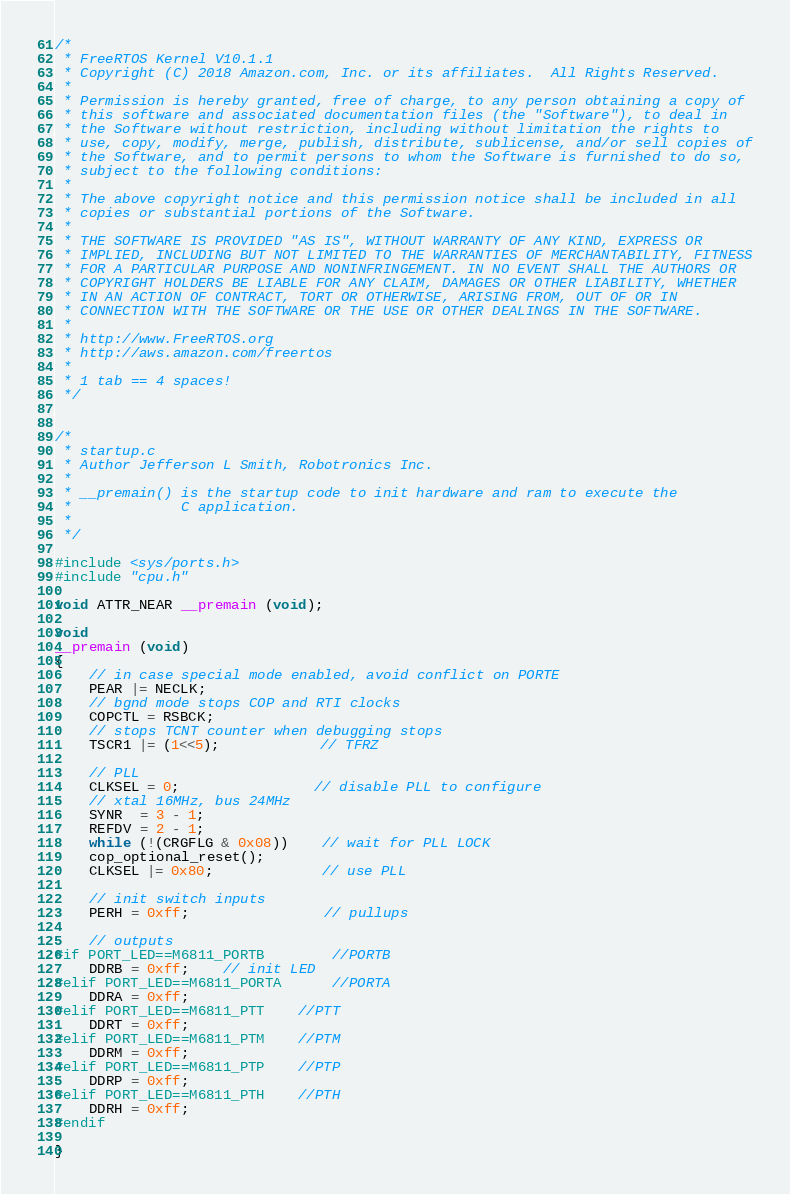Convert code to text. <code><loc_0><loc_0><loc_500><loc_500><_C_>/*
 * FreeRTOS Kernel V10.1.1
 * Copyright (C) 2018 Amazon.com, Inc. or its affiliates.  All Rights Reserved.
 *
 * Permission is hereby granted, free of charge, to any person obtaining a copy of
 * this software and associated documentation files (the "Software"), to deal in
 * the Software without restriction, including without limitation the rights to
 * use, copy, modify, merge, publish, distribute, sublicense, and/or sell copies of
 * the Software, and to permit persons to whom the Software is furnished to do so,
 * subject to the following conditions:
 *
 * The above copyright notice and this permission notice shall be included in all
 * copies or substantial portions of the Software.
 *
 * THE SOFTWARE IS PROVIDED "AS IS", WITHOUT WARRANTY OF ANY KIND, EXPRESS OR
 * IMPLIED, INCLUDING BUT NOT LIMITED TO THE WARRANTIES OF MERCHANTABILITY, FITNESS
 * FOR A PARTICULAR PURPOSE AND NONINFRINGEMENT. IN NO EVENT SHALL THE AUTHORS OR
 * COPYRIGHT HOLDERS BE LIABLE FOR ANY CLAIM, DAMAGES OR OTHER LIABILITY, WHETHER
 * IN AN ACTION OF CONTRACT, TORT OR OTHERWISE, ARISING FROM, OUT OF OR IN
 * CONNECTION WITH THE SOFTWARE OR THE USE OR OTHER DEALINGS IN THE SOFTWARE.
 *
 * http://www.FreeRTOS.org
 * http://aws.amazon.com/freertos
 *
 * 1 tab == 4 spaces!
 */


/*
 * startup.c
 * Author Jefferson L Smith, Robotronics Inc.
 *
 * __premain() is the startup code to init hardware and ram to execute the
 *             C application.
 *
 */

#include <sys/ports.h>
#include "cpu.h"

void ATTR_NEAR __premain (void);

void
__premain (void)
{
	// in case special mode enabled, avoid conflict on PORTE
	PEAR |= NECLK;
	// bgnd mode stops COP and RTI clocks
	COPCTL = RSBCK;
	// stops TCNT counter when debugging stops
	TSCR1 |= (1<<5);			// TFRZ
	
	// PLL
	CLKSEL = 0;				// disable PLL to configure
	// xtal 16MHz, bus 24MHz
	SYNR  = 3 - 1;
	REFDV = 2 - 1;
	while (!(CRGFLG & 0x08))    // wait for PLL LOCK
	cop_optional_reset();
	CLKSEL |= 0x80;             // use PLL

	// init switch inputs
	PERH = 0xff;				// pullups

	// outputs
#if PORT_LED==M6811_PORTB		//PORTB
	DDRB = 0xff;	// init LED
#elif PORT_LED==M6811_PORTA		//PORTA
	DDRA = 0xff;
#elif PORT_LED==M6811_PTT	//PTT
	DDRT = 0xff;
#elif PORT_LED==M6811_PTM	//PTM
	DDRM = 0xff;
#elif PORT_LED==M6811_PTP	//PTP
	DDRP = 0xff;
#elif PORT_LED==M6811_PTH	//PTH
	DDRH = 0xff;
#endif
	
}

</code> 